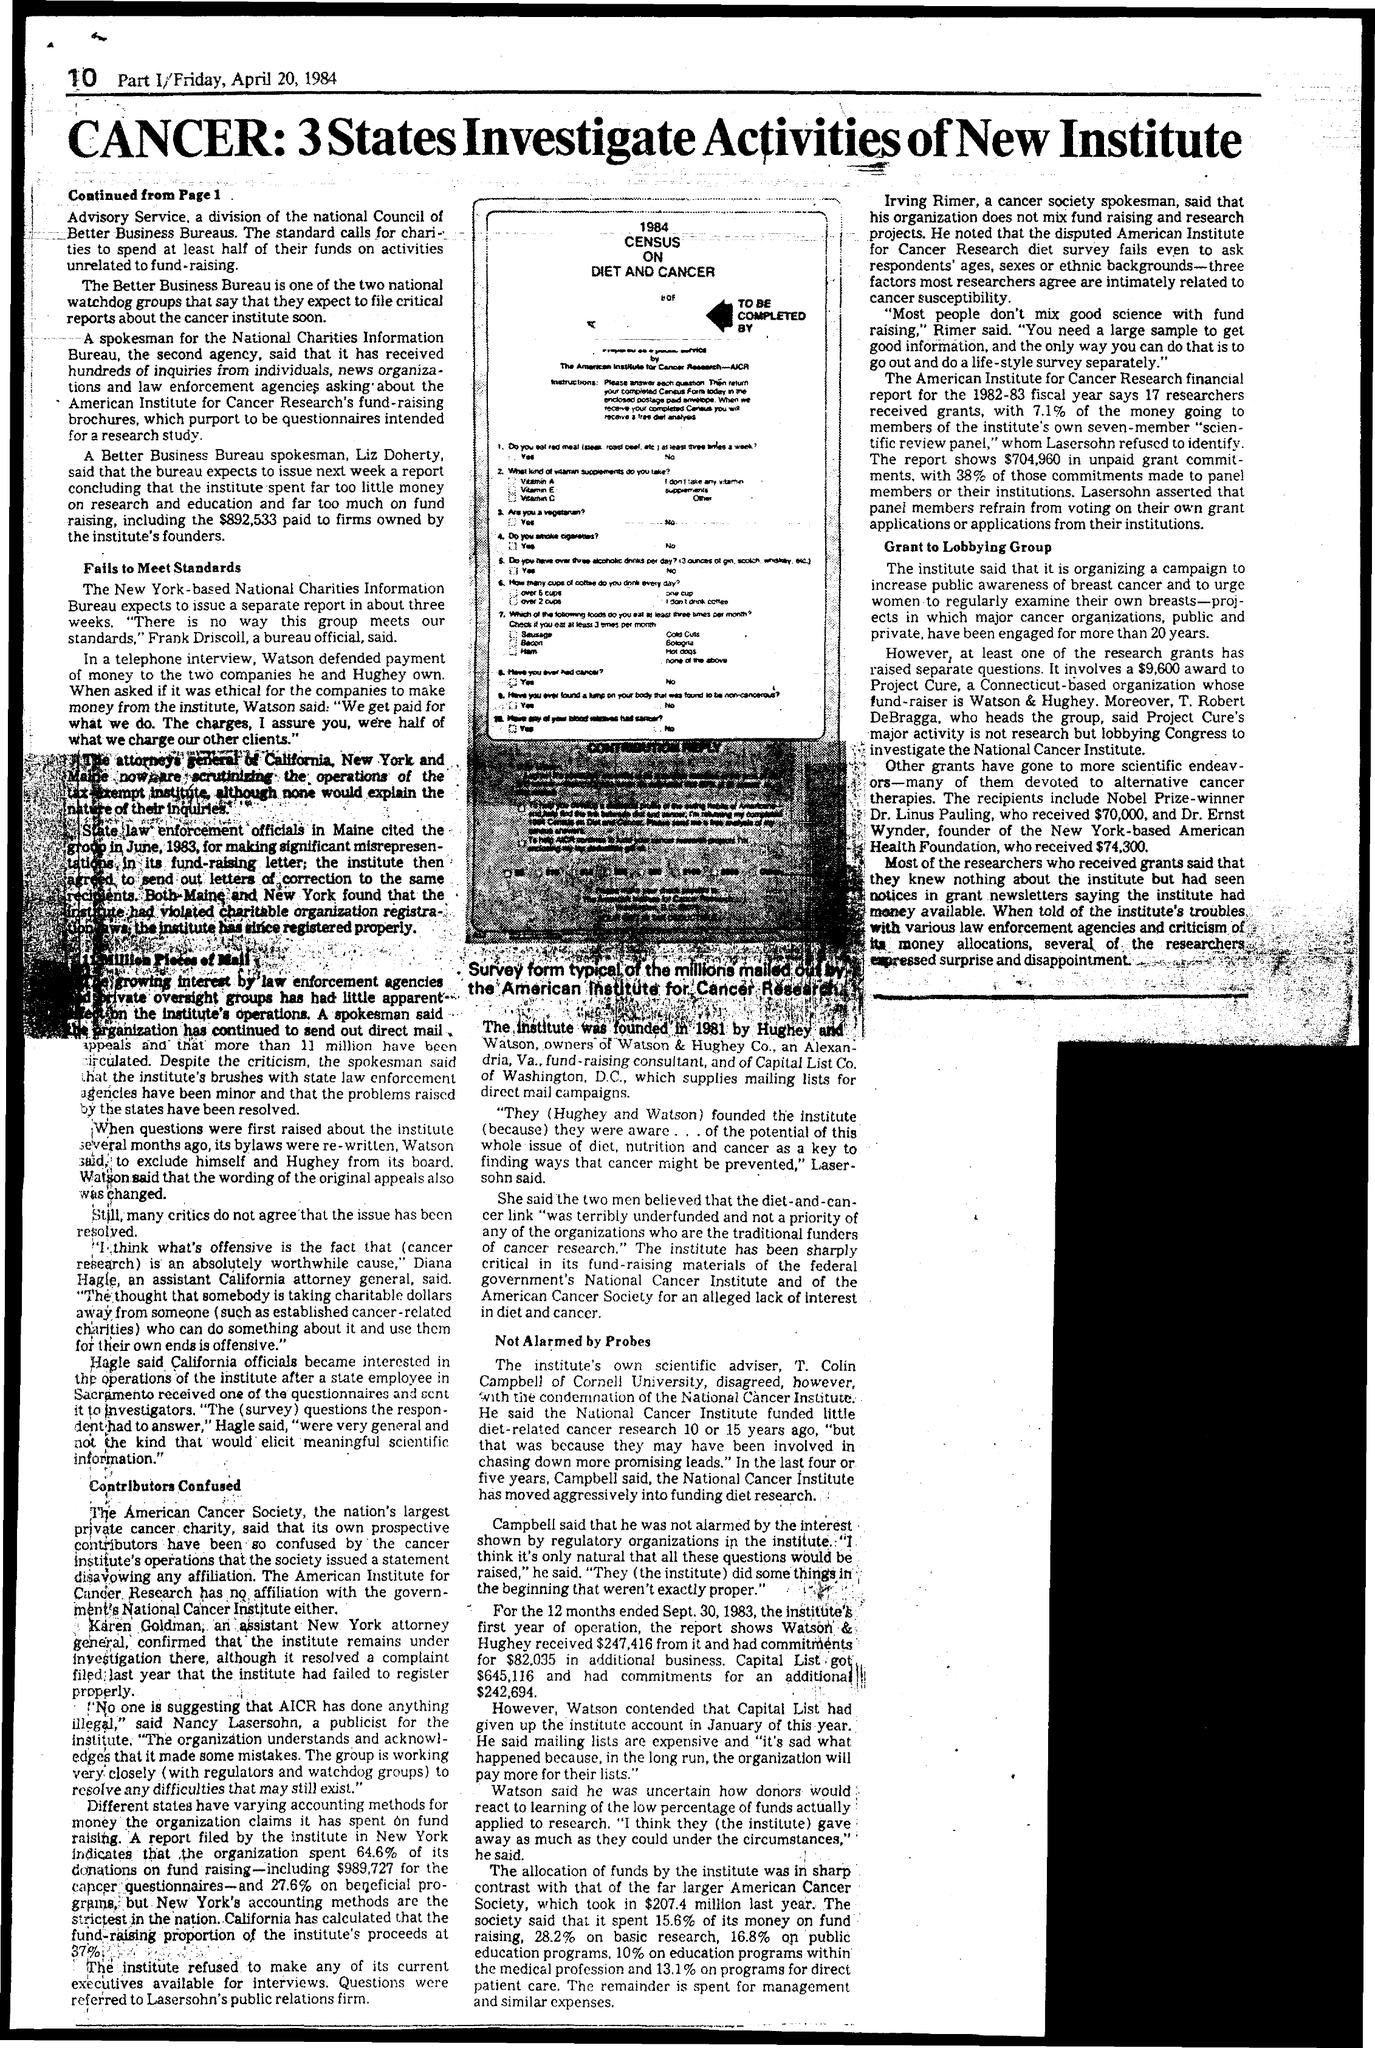Point out several critical features in this image. The Institute was established in the year 1981. 